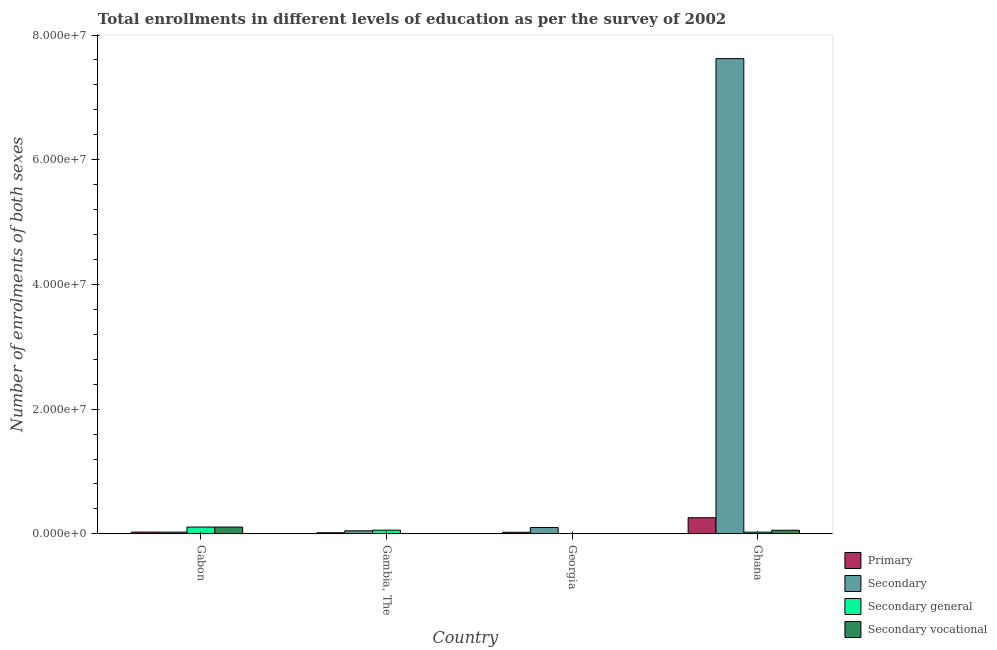Are the number of bars on each tick of the X-axis equal?
Your response must be concise. Yes. How many bars are there on the 1st tick from the left?
Provide a succinct answer. 4. What is the label of the 1st group of bars from the left?
Offer a terse response. Gabon. In how many cases, is the number of bars for a given country not equal to the number of legend labels?
Make the answer very short. 0. What is the number of enrolments in primary education in Ghana?
Ensure brevity in your answer.  2.59e+06. Across all countries, what is the maximum number of enrolments in secondary vocational education?
Your answer should be compact. 1.09e+06. Across all countries, what is the minimum number of enrolments in primary education?
Your response must be concise. 1.83e+05. In which country was the number of enrolments in secondary general education maximum?
Give a very brief answer. Gabon. In which country was the number of enrolments in secondary vocational education minimum?
Offer a very short reply. Georgia. What is the total number of enrolments in secondary vocational education in the graph?
Keep it short and to the point. 1.73e+06. What is the difference between the number of enrolments in secondary vocational education in Gambia, The and that in Ghana?
Your response must be concise. -5.38e+05. What is the difference between the number of enrolments in secondary general education in Gambia, The and the number of enrolments in secondary education in Gabon?
Ensure brevity in your answer.  3.18e+05. What is the average number of enrolments in primary education per country?
Provide a short and direct response. 8.26e+05. What is the difference between the number of enrolments in secondary general education and number of enrolments in secondary education in Ghana?
Give a very brief answer. -7.59e+07. What is the ratio of the number of enrolments in secondary education in Gabon to that in Ghana?
Keep it short and to the point. 0. Is the number of enrolments in secondary vocational education in Gambia, The less than that in Georgia?
Ensure brevity in your answer.  No. What is the difference between the highest and the second highest number of enrolments in primary education?
Provide a succinct answer. 2.30e+06. What is the difference between the highest and the lowest number of enrolments in primary education?
Give a very brief answer. 2.40e+06. Is it the case that in every country, the sum of the number of enrolments in secondary education and number of enrolments in primary education is greater than the sum of number of enrolments in secondary vocational education and number of enrolments in secondary general education?
Offer a very short reply. Yes. What does the 2nd bar from the left in Gambia, The represents?
Offer a very short reply. Secondary. What does the 4th bar from the right in Ghana represents?
Offer a terse response. Primary. How many bars are there?
Make the answer very short. 16. Does the graph contain grids?
Your response must be concise. No. What is the title of the graph?
Ensure brevity in your answer.  Total enrollments in different levels of education as per the survey of 2002. What is the label or title of the Y-axis?
Provide a succinct answer. Number of enrolments of both sexes. What is the Number of enrolments of both sexes of Primary in Gabon?
Ensure brevity in your answer.  2.82e+05. What is the Number of enrolments of both sexes in Secondary in Gabon?
Offer a terse response. 2.76e+05. What is the Number of enrolments of both sexes of Secondary general in Gabon?
Provide a succinct answer. 1.09e+06. What is the Number of enrolments of both sexes in Secondary vocational in Gabon?
Offer a very short reply. 1.09e+06. What is the Number of enrolments of both sexes of Primary in Gambia, The?
Offer a very short reply. 1.83e+05. What is the Number of enrolments of both sexes in Secondary in Gambia, The?
Provide a succinct answer. 4.89e+05. What is the Number of enrolments of both sexes of Secondary general in Gambia, The?
Offer a terse response. 5.94e+05. What is the Number of enrolments of both sexes in Secondary vocational in Gambia, The?
Give a very brief answer. 4.25e+04. What is the Number of enrolments of both sexes of Primary in Georgia?
Your answer should be compact. 2.55e+05. What is the Number of enrolments of both sexes in Secondary in Georgia?
Keep it short and to the point. 1.01e+06. What is the Number of enrolments of both sexes in Secondary general in Georgia?
Ensure brevity in your answer.  1.32e+04. What is the Number of enrolments of both sexes of Secondary vocational in Georgia?
Ensure brevity in your answer.  1.47e+04. What is the Number of enrolments of both sexes in Primary in Ghana?
Keep it short and to the point. 2.59e+06. What is the Number of enrolments of both sexes in Secondary in Ghana?
Provide a succinct answer. 7.62e+07. What is the Number of enrolments of both sexes in Secondary general in Ghana?
Your response must be concise. 2.71e+05. What is the Number of enrolments of both sexes in Secondary vocational in Ghana?
Your answer should be very brief. 5.80e+05. Across all countries, what is the maximum Number of enrolments of both sexes of Primary?
Give a very brief answer. 2.59e+06. Across all countries, what is the maximum Number of enrolments of both sexes of Secondary?
Give a very brief answer. 7.62e+07. Across all countries, what is the maximum Number of enrolments of both sexes of Secondary general?
Make the answer very short. 1.09e+06. Across all countries, what is the maximum Number of enrolments of both sexes of Secondary vocational?
Offer a terse response. 1.09e+06. Across all countries, what is the minimum Number of enrolments of both sexes of Primary?
Your answer should be very brief. 1.83e+05. Across all countries, what is the minimum Number of enrolments of both sexes in Secondary?
Your answer should be compact. 2.76e+05. Across all countries, what is the minimum Number of enrolments of both sexes of Secondary general?
Keep it short and to the point. 1.32e+04. Across all countries, what is the minimum Number of enrolments of both sexes in Secondary vocational?
Your response must be concise. 1.47e+04. What is the total Number of enrolments of both sexes of Primary in the graph?
Give a very brief answer. 3.31e+06. What is the total Number of enrolments of both sexes in Secondary in the graph?
Make the answer very short. 7.80e+07. What is the total Number of enrolments of both sexes in Secondary general in the graph?
Offer a very short reply. 1.97e+06. What is the total Number of enrolments of both sexes of Secondary vocational in the graph?
Make the answer very short. 1.73e+06. What is the difference between the Number of enrolments of both sexes in Primary in Gabon and that in Gambia, The?
Offer a very short reply. 9.93e+04. What is the difference between the Number of enrolments of both sexes of Secondary in Gabon and that in Gambia, The?
Offer a very short reply. -2.12e+05. What is the difference between the Number of enrolments of both sexes of Secondary general in Gabon and that in Gambia, The?
Make the answer very short. 4.98e+05. What is the difference between the Number of enrolments of both sexes in Secondary vocational in Gabon and that in Gambia, The?
Make the answer very short. 1.05e+06. What is the difference between the Number of enrolments of both sexes of Primary in Gabon and that in Georgia?
Keep it short and to the point. 2.68e+04. What is the difference between the Number of enrolments of both sexes in Secondary in Gabon and that in Georgia?
Your answer should be compact. -7.37e+05. What is the difference between the Number of enrolments of both sexes of Secondary general in Gabon and that in Georgia?
Make the answer very short. 1.08e+06. What is the difference between the Number of enrolments of both sexes of Secondary vocational in Gabon and that in Georgia?
Make the answer very short. 1.08e+06. What is the difference between the Number of enrolments of both sexes of Primary in Gabon and that in Ghana?
Provide a succinct answer. -2.30e+06. What is the difference between the Number of enrolments of both sexes of Secondary in Gabon and that in Ghana?
Give a very brief answer. -7.59e+07. What is the difference between the Number of enrolments of both sexes of Secondary general in Gabon and that in Ghana?
Give a very brief answer. 8.21e+05. What is the difference between the Number of enrolments of both sexes in Secondary vocational in Gabon and that in Ghana?
Keep it short and to the point. 5.11e+05. What is the difference between the Number of enrolments of both sexes in Primary in Gambia, The and that in Georgia?
Offer a terse response. -7.25e+04. What is the difference between the Number of enrolments of both sexes of Secondary in Gambia, The and that in Georgia?
Your answer should be very brief. -5.25e+05. What is the difference between the Number of enrolments of both sexes of Secondary general in Gambia, The and that in Georgia?
Give a very brief answer. 5.81e+05. What is the difference between the Number of enrolments of both sexes of Secondary vocational in Gambia, The and that in Georgia?
Ensure brevity in your answer.  2.78e+04. What is the difference between the Number of enrolments of both sexes of Primary in Gambia, The and that in Ghana?
Give a very brief answer. -2.40e+06. What is the difference between the Number of enrolments of both sexes of Secondary in Gambia, The and that in Ghana?
Provide a short and direct response. -7.57e+07. What is the difference between the Number of enrolments of both sexes of Secondary general in Gambia, The and that in Ghana?
Give a very brief answer. 3.23e+05. What is the difference between the Number of enrolments of both sexes in Secondary vocational in Gambia, The and that in Ghana?
Ensure brevity in your answer.  -5.38e+05. What is the difference between the Number of enrolments of both sexes of Primary in Georgia and that in Ghana?
Make the answer very short. -2.33e+06. What is the difference between the Number of enrolments of both sexes in Secondary in Georgia and that in Ghana?
Provide a short and direct response. -7.52e+07. What is the difference between the Number of enrolments of both sexes of Secondary general in Georgia and that in Ghana?
Offer a terse response. -2.58e+05. What is the difference between the Number of enrolments of both sexes of Secondary vocational in Georgia and that in Ghana?
Your response must be concise. -5.66e+05. What is the difference between the Number of enrolments of both sexes in Primary in Gabon and the Number of enrolments of both sexes in Secondary in Gambia, The?
Give a very brief answer. -2.07e+05. What is the difference between the Number of enrolments of both sexes in Primary in Gabon and the Number of enrolments of both sexes in Secondary general in Gambia, The?
Ensure brevity in your answer.  -3.12e+05. What is the difference between the Number of enrolments of both sexes of Primary in Gabon and the Number of enrolments of both sexes of Secondary vocational in Gambia, The?
Offer a terse response. 2.39e+05. What is the difference between the Number of enrolments of both sexes of Secondary in Gabon and the Number of enrolments of both sexes of Secondary general in Gambia, The?
Provide a short and direct response. -3.18e+05. What is the difference between the Number of enrolments of both sexes in Secondary in Gabon and the Number of enrolments of both sexes in Secondary vocational in Gambia, The?
Offer a very short reply. 2.34e+05. What is the difference between the Number of enrolments of both sexes of Secondary general in Gabon and the Number of enrolments of both sexes of Secondary vocational in Gambia, The?
Provide a succinct answer. 1.05e+06. What is the difference between the Number of enrolments of both sexes of Primary in Gabon and the Number of enrolments of both sexes of Secondary in Georgia?
Provide a short and direct response. -7.32e+05. What is the difference between the Number of enrolments of both sexes in Primary in Gabon and the Number of enrolments of both sexes in Secondary general in Georgia?
Offer a terse response. 2.69e+05. What is the difference between the Number of enrolments of both sexes of Primary in Gabon and the Number of enrolments of both sexes of Secondary vocational in Georgia?
Offer a terse response. 2.67e+05. What is the difference between the Number of enrolments of both sexes in Secondary in Gabon and the Number of enrolments of both sexes in Secondary general in Georgia?
Ensure brevity in your answer.  2.63e+05. What is the difference between the Number of enrolments of both sexes in Secondary in Gabon and the Number of enrolments of both sexes in Secondary vocational in Georgia?
Ensure brevity in your answer.  2.61e+05. What is the difference between the Number of enrolments of both sexes in Secondary general in Gabon and the Number of enrolments of both sexes in Secondary vocational in Georgia?
Keep it short and to the point. 1.08e+06. What is the difference between the Number of enrolments of both sexes of Primary in Gabon and the Number of enrolments of both sexes of Secondary in Ghana?
Your answer should be very brief. -7.59e+07. What is the difference between the Number of enrolments of both sexes of Primary in Gabon and the Number of enrolments of both sexes of Secondary general in Ghana?
Give a very brief answer. 1.08e+04. What is the difference between the Number of enrolments of both sexes of Primary in Gabon and the Number of enrolments of both sexes of Secondary vocational in Ghana?
Offer a very short reply. -2.98e+05. What is the difference between the Number of enrolments of both sexes in Secondary in Gabon and the Number of enrolments of both sexes in Secondary general in Ghana?
Make the answer very short. 4995. What is the difference between the Number of enrolments of both sexes of Secondary in Gabon and the Number of enrolments of both sexes of Secondary vocational in Ghana?
Your answer should be very brief. -3.04e+05. What is the difference between the Number of enrolments of both sexes in Secondary general in Gabon and the Number of enrolments of both sexes in Secondary vocational in Ghana?
Give a very brief answer. 5.12e+05. What is the difference between the Number of enrolments of both sexes of Primary in Gambia, The and the Number of enrolments of both sexes of Secondary in Georgia?
Offer a very short reply. -8.31e+05. What is the difference between the Number of enrolments of both sexes in Primary in Gambia, The and the Number of enrolments of both sexes in Secondary general in Georgia?
Your answer should be very brief. 1.69e+05. What is the difference between the Number of enrolments of both sexes in Primary in Gambia, The and the Number of enrolments of both sexes in Secondary vocational in Georgia?
Offer a terse response. 1.68e+05. What is the difference between the Number of enrolments of both sexes in Secondary in Gambia, The and the Number of enrolments of both sexes in Secondary general in Georgia?
Give a very brief answer. 4.75e+05. What is the difference between the Number of enrolments of both sexes in Secondary in Gambia, The and the Number of enrolments of both sexes in Secondary vocational in Georgia?
Your response must be concise. 4.74e+05. What is the difference between the Number of enrolments of both sexes of Secondary general in Gambia, The and the Number of enrolments of both sexes of Secondary vocational in Georgia?
Ensure brevity in your answer.  5.80e+05. What is the difference between the Number of enrolments of both sexes in Primary in Gambia, The and the Number of enrolments of both sexes in Secondary in Ghana?
Offer a terse response. -7.60e+07. What is the difference between the Number of enrolments of both sexes of Primary in Gambia, The and the Number of enrolments of both sexes of Secondary general in Ghana?
Offer a very short reply. -8.85e+04. What is the difference between the Number of enrolments of both sexes of Primary in Gambia, The and the Number of enrolments of both sexes of Secondary vocational in Ghana?
Give a very brief answer. -3.98e+05. What is the difference between the Number of enrolments of both sexes of Secondary in Gambia, The and the Number of enrolments of both sexes of Secondary general in Ghana?
Give a very brief answer. 2.17e+05. What is the difference between the Number of enrolments of both sexes of Secondary in Gambia, The and the Number of enrolments of both sexes of Secondary vocational in Ghana?
Ensure brevity in your answer.  -9.17e+04. What is the difference between the Number of enrolments of both sexes in Secondary general in Gambia, The and the Number of enrolments of both sexes in Secondary vocational in Ghana?
Offer a terse response. 1.41e+04. What is the difference between the Number of enrolments of both sexes of Primary in Georgia and the Number of enrolments of both sexes of Secondary in Ghana?
Make the answer very short. -7.60e+07. What is the difference between the Number of enrolments of both sexes in Primary in Georgia and the Number of enrolments of both sexes in Secondary general in Ghana?
Ensure brevity in your answer.  -1.61e+04. What is the difference between the Number of enrolments of both sexes in Primary in Georgia and the Number of enrolments of both sexes in Secondary vocational in Ghana?
Make the answer very short. -3.25e+05. What is the difference between the Number of enrolments of both sexes in Secondary in Georgia and the Number of enrolments of both sexes in Secondary general in Ghana?
Make the answer very short. 7.42e+05. What is the difference between the Number of enrolments of both sexes of Secondary in Georgia and the Number of enrolments of both sexes of Secondary vocational in Ghana?
Your answer should be compact. 4.33e+05. What is the difference between the Number of enrolments of both sexes of Secondary general in Georgia and the Number of enrolments of both sexes of Secondary vocational in Ghana?
Provide a short and direct response. -5.67e+05. What is the average Number of enrolments of both sexes of Primary per country?
Offer a terse response. 8.26e+05. What is the average Number of enrolments of both sexes of Secondary per country?
Give a very brief answer. 1.95e+07. What is the average Number of enrolments of both sexes of Secondary general per country?
Offer a terse response. 4.93e+05. What is the average Number of enrolments of both sexes in Secondary vocational per country?
Your answer should be compact. 4.32e+05. What is the difference between the Number of enrolments of both sexes in Primary and Number of enrolments of both sexes in Secondary in Gabon?
Your response must be concise. 5787. What is the difference between the Number of enrolments of both sexes in Primary and Number of enrolments of both sexes in Secondary general in Gabon?
Provide a succinct answer. -8.10e+05. What is the difference between the Number of enrolments of both sexes in Primary and Number of enrolments of both sexes in Secondary vocational in Gabon?
Your answer should be very brief. -8.10e+05. What is the difference between the Number of enrolments of both sexes in Secondary and Number of enrolments of both sexes in Secondary general in Gabon?
Ensure brevity in your answer.  -8.16e+05. What is the difference between the Number of enrolments of both sexes in Secondary and Number of enrolments of both sexes in Secondary vocational in Gabon?
Offer a very short reply. -8.16e+05. What is the difference between the Number of enrolments of both sexes in Secondary general and Number of enrolments of both sexes in Secondary vocational in Gabon?
Your answer should be very brief. 635. What is the difference between the Number of enrolments of both sexes in Primary and Number of enrolments of both sexes in Secondary in Gambia, The?
Provide a short and direct response. -3.06e+05. What is the difference between the Number of enrolments of both sexes of Primary and Number of enrolments of both sexes of Secondary general in Gambia, The?
Offer a very short reply. -4.12e+05. What is the difference between the Number of enrolments of both sexes of Primary and Number of enrolments of both sexes of Secondary vocational in Gambia, The?
Make the answer very short. 1.40e+05. What is the difference between the Number of enrolments of both sexes in Secondary and Number of enrolments of both sexes in Secondary general in Gambia, The?
Give a very brief answer. -1.06e+05. What is the difference between the Number of enrolments of both sexes in Secondary and Number of enrolments of both sexes in Secondary vocational in Gambia, The?
Offer a terse response. 4.46e+05. What is the difference between the Number of enrolments of both sexes of Secondary general and Number of enrolments of both sexes of Secondary vocational in Gambia, The?
Make the answer very short. 5.52e+05. What is the difference between the Number of enrolments of both sexes in Primary and Number of enrolments of both sexes in Secondary in Georgia?
Offer a terse response. -7.58e+05. What is the difference between the Number of enrolments of both sexes in Primary and Number of enrolments of both sexes in Secondary general in Georgia?
Ensure brevity in your answer.  2.42e+05. What is the difference between the Number of enrolments of both sexes in Primary and Number of enrolments of both sexes in Secondary vocational in Georgia?
Offer a terse response. 2.40e+05. What is the difference between the Number of enrolments of both sexes in Secondary and Number of enrolments of both sexes in Secondary general in Georgia?
Give a very brief answer. 1.00e+06. What is the difference between the Number of enrolments of both sexes in Secondary and Number of enrolments of both sexes in Secondary vocational in Georgia?
Provide a succinct answer. 9.99e+05. What is the difference between the Number of enrolments of both sexes of Secondary general and Number of enrolments of both sexes of Secondary vocational in Georgia?
Provide a succinct answer. -1450. What is the difference between the Number of enrolments of both sexes in Primary and Number of enrolments of both sexes in Secondary in Ghana?
Keep it short and to the point. -7.36e+07. What is the difference between the Number of enrolments of both sexes of Primary and Number of enrolments of both sexes of Secondary general in Ghana?
Your answer should be compact. 2.32e+06. What is the difference between the Number of enrolments of both sexes of Primary and Number of enrolments of both sexes of Secondary vocational in Ghana?
Provide a succinct answer. 2.01e+06. What is the difference between the Number of enrolments of both sexes of Secondary and Number of enrolments of both sexes of Secondary general in Ghana?
Offer a terse response. 7.59e+07. What is the difference between the Number of enrolments of both sexes in Secondary and Number of enrolments of both sexes in Secondary vocational in Ghana?
Make the answer very short. 7.56e+07. What is the difference between the Number of enrolments of both sexes in Secondary general and Number of enrolments of both sexes in Secondary vocational in Ghana?
Your answer should be compact. -3.09e+05. What is the ratio of the Number of enrolments of both sexes in Primary in Gabon to that in Gambia, The?
Ensure brevity in your answer.  1.54. What is the ratio of the Number of enrolments of both sexes in Secondary in Gabon to that in Gambia, The?
Your answer should be very brief. 0.57. What is the ratio of the Number of enrolments of both sexes of Secondary general in Gabon to that in Gambia, The?
Offer a terse response. 1.84. What is the ratio of the Number of enrolments of both sexes in Secondary vocational in Gabon to that in Gambia, The?
Give a very brief answer. 25.7. What is the ratio of the Number of enrolments of both sexes in Primary in Gabon to that in Georgia?
Ensure brevity in your answer.  1.11. What is the ratio of the Number of enrolments of both sexes of Secondary in Gabon to that in Georgia?
Give a very brief answer. 0.27. What is the ratio of the Number of enrolments of both sexes of Secondary general in Gabon to that in Georgia?
Provide a short and direct response. 82.66. What is the ratio of the Number of enrolments of both sexes of Secondary vocational in Gabon to that in Georgia?
Your answer should be compact. 74.45. What is the ratio of the Number of enrolments of both sexes of Primary in Gabon to that in Ghana?
Your response must be concise. 0.11. What is the ratio of the Number of enrolments of both sexes of Secondary in Gabon to that in Ghana?
Provide a succinct answer. 0. What is the ratio of the Number of enrolments of both sexes in Secondary general in Gabon to that in Ghana?
Your response must be concise. 4.03. What is the ratio of the Number of enrolments of both sexes in Secondary vocational in Gabon to that in Ghana?
Keep it short and to the point. 1.88. What is the ratio of the Number of enrolments of both sexes of Primary in Gambia, The to that in Georgia?
Your response must be concise. 0.72. What is the ratio of the Number of enrolments of both sexes in Secondary in Gambia, The to that in Georgia?
Your answer should be compact. 0.48. What is the ratio of the Number of enrolments of both sexes of Secondary general in Gambia, The to that in Georgia?
Your answer should be very brief. 44.98. What is the ratio of the Number of enrolments of both sexes of Secondary vocational in Gambia, The to that in Georgia?
Provide a short and direct response. 2.9. What is the ratio of the Number of enrolments of both sexes in Primary in Gambia, The to that in Ghana?
Make the answer very short. 0.07. What is the ratio of the Number of enrolments of both sexes in Secondary in Gambia, The to that in Ghana?
Give a very brief answer. 0.01. What is the ratio of the Number of enrolments of both sexes in Secondary general in Gambia, The to that in Ghana?
Ensure brevity in your answer.  2.19. What is the ratio of the Number of enrolments of both sexes in Secondary vocational in Gambia, The to that in Ghana?
Make the answer very short. 0.07. What is the ratio of the Number of enrolments of both sexes of Primary in Georgia to that in Ghana?
Offer a very short reply. 0.1. What is the ratio of the Number of enrolments of both sexes of Secondary in Georgia to that in Ghana?
Your answer should be compact. 0.01. What is the ratio of the Number of enrolments of both sexes in Secondary general in Georgia to that in Ghana?
Your response must be concise. 0.05. What is the ratio of the Number of enrolments of both sexes in Secondary vocational in Georgia to that in Ghana?
Give a very brief answer. 0.03. What is the difference between the highest and the second highest Number of enrolments of both sexes of Primary?
Ensure brevity in your answer.  2.30e+06. What is the difference between the highest and the second highest Number of enrolments of both sexes of Secondary?
Your answer should be compact. 7.52e+07. What is the difference between the highest and the second highest Number of enrolments of both sexes of Secondary general?
Your answer should be very brief. 4.98e+05. What is the difference between the highest and the second highest Number of enrolments of both sexes of Secondary vocational?
Your answer should be compact. 5.11e+05. What is the difference between the highest and the lowest Number of enrolments of both sexes in Primary?
Your answer should be very brief. 2.40e+06. What is the difference between the highest and the lowest Number of enrolments of both sexes of Secondary?
Provide a succinct answer. 7.59e+07. What is the difference between the highest and the lowest Number of enrolments of both sexes of Secondary general?
Make the answer very short. 1.08e+06. What is the difference between the highest and the lowest Number of enrolments of both sexes of Secondary vocational?
Provide a succinct answer. 1.08e+06. 